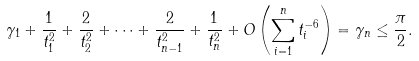<formula> <loc_0><loc_0><loc_500><loc_500>\gamma _ { 1 } + \frac { 1 } { t _ { 1 } ^ { 2 } } + \frac { 2 } { t _ { 2 } ^ { 2 } } + \dots + \frac { 2 } { t _ { n - 1 } ^ { 2 } } + \frac { 1 } { t _ { n } ^ { 2 } } + O \left ( \sum _ { i = 1 } ^ { n } t _ { i } ^ { - 6 } \right ) = \gamma _ { n } \leq \frac { \pi } { 2 } .</formula> 